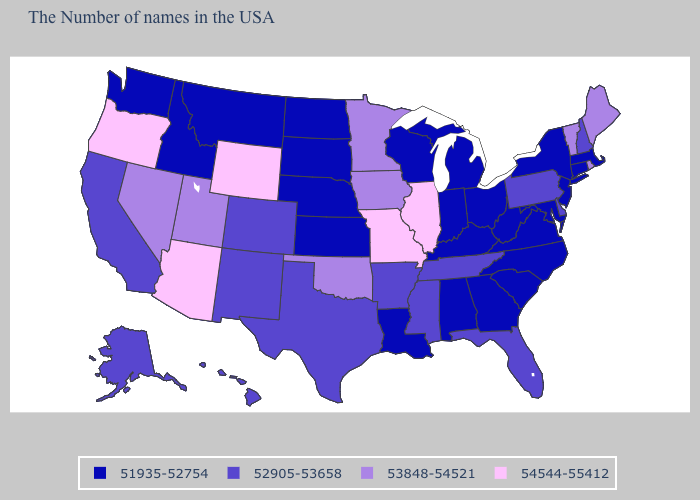What is the value of Oklahoma?
Give a very brief answer. 53848-54521. Name the states that have a value in the range 54544-55412?
Keep it brief. Illinois, Missouri, Wyoming, Arizona, Oregon. Which states have the lowest value in the West?
Write a very short answer. Montana, Idaho, Washington. How many symbols are there in the legend?
Give a very brief answer. 4. Which states have the lowest value in the USA?
Keep it brief. Massachusetts, Connecticut, New York, New Jersey, Maryland, Virginia, North Carolina, South Carolina, West Virginia, Ohio, Georgia, Michigan, Kentucky, Indiana, Alabama, Wisconsin, Louisiana, Kansas, Nebraska, South Dakota, North Dakota, Montana, Idaho, Washington. Which states hav the highest value in the MidWest?
Quick response, please. Illinois, Missouri. Name the states that have a value in the range 53848-54521?
Keep it brief. Maine, Rhode Island, Vermont, Minnesota, Iowa, Oklahoma, Utah, Nevada. Among the states that border Rhode Island , which have the highest value?
Give a very brief answer. Massachusetts, Connecticut. Does Wyoming have a higher value than Arizona?
Short answer required. No. Among the states that border California , which have the lowest value?
Concise answer only. Nevada. Name the states that have a value in the range 54544-55412?
Concise answer only. Illinois, Missouri, Wyoming, Arizona, Oregon. Name the states that have a value in the range 51935-52754?
Keep it brief. Massachusetts, Connecticut, New York, New Jersey, Maryland, Virginia, North Carolina, South Carolina, West Virginia, Ohio, Georgia, Michigan, Kentucky, Indiana, Alabama, Wisconsin, Louisiana, Kansas, Nebraska, South Dakota, North Dakota, Montana, Idaho, Washington. Does New York have the lowest value in the Northeast?
Keep it brief. Yes. Which states have the lowest value in the USA?
Keep it brief. Massachusetts, Connecticut, New York, New Jersey, Maryland, Virginia, North Carolina, South Carolina, West Virginia, Ohio, Georgia, Michigan, Kentucky, Indiana, Alabama, Wisconsin, Louisiana, Kansas, Nebraska, South Dakota, North Dakota, Montana, Idaho, Washington. What is the value of Hawaii?
Keep it brief. 52905-53658. 